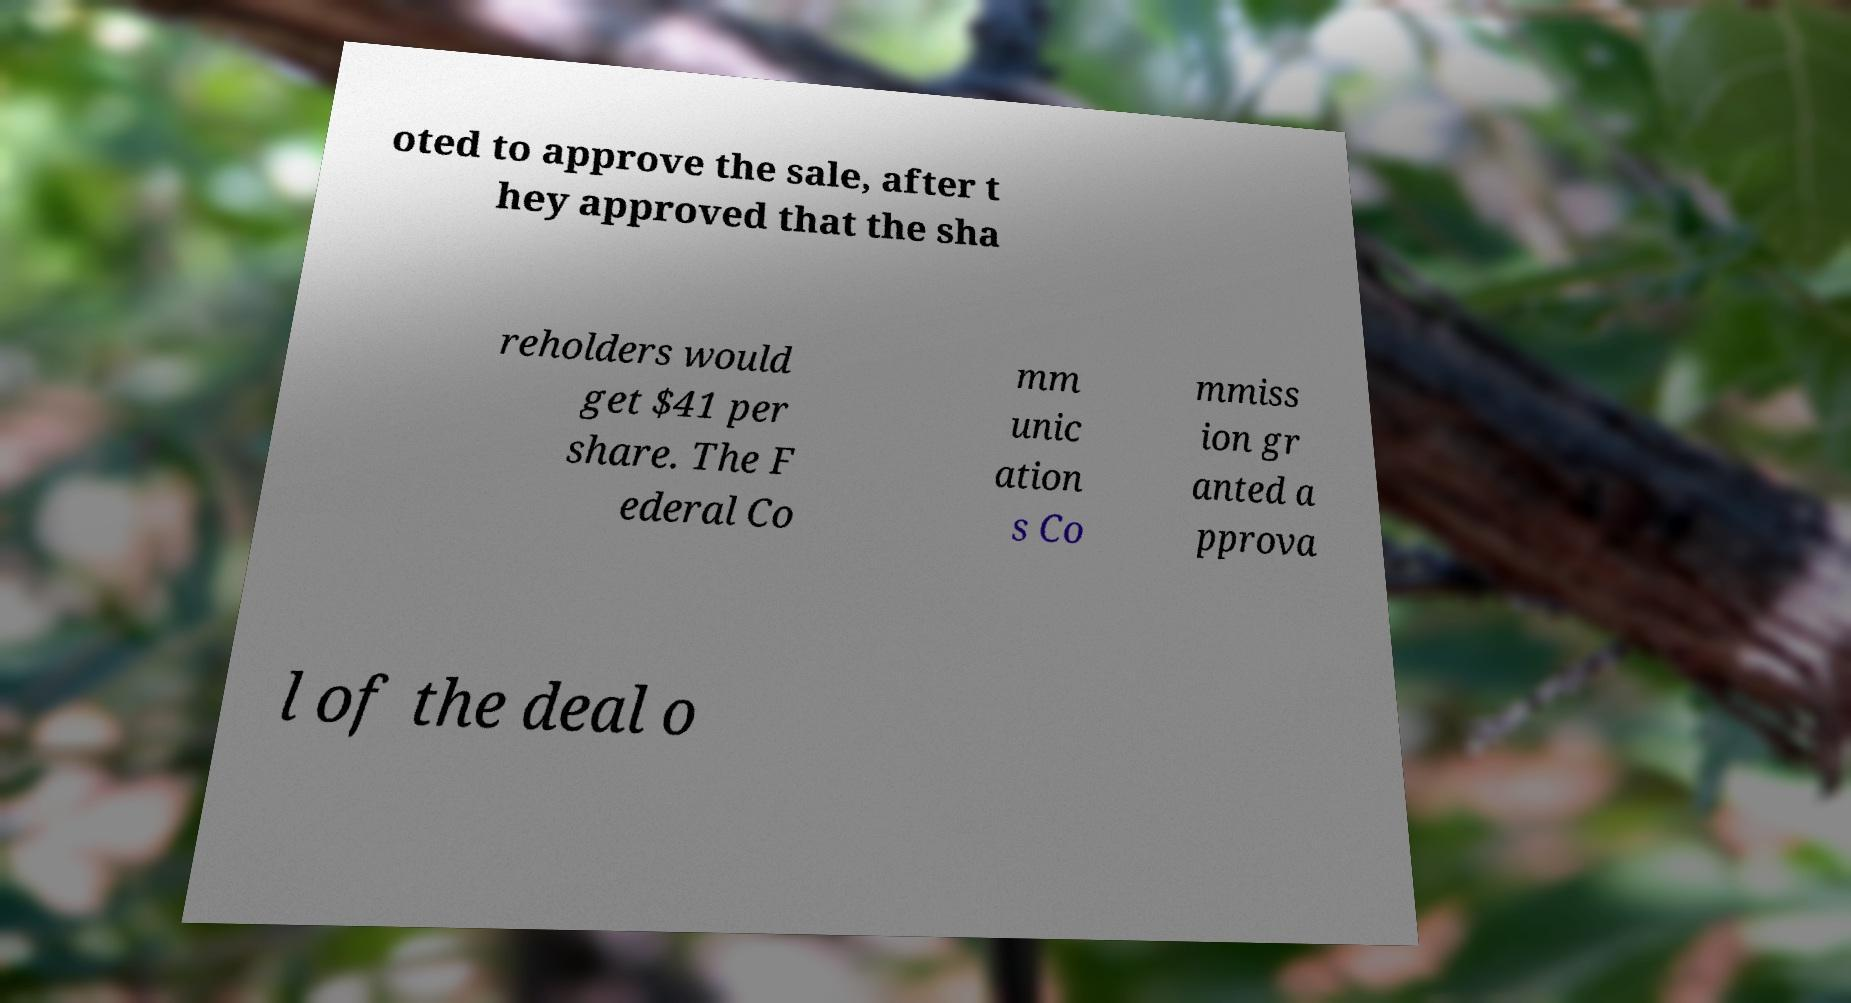I need the written content from this picture converted into text. Can you do that? oted to approve the sale, after t hey approved that the sha reholders would get $41 per share. The F ederal Co mm unic ation s Co mmiss ion gr anted a pprova l of the deal o 